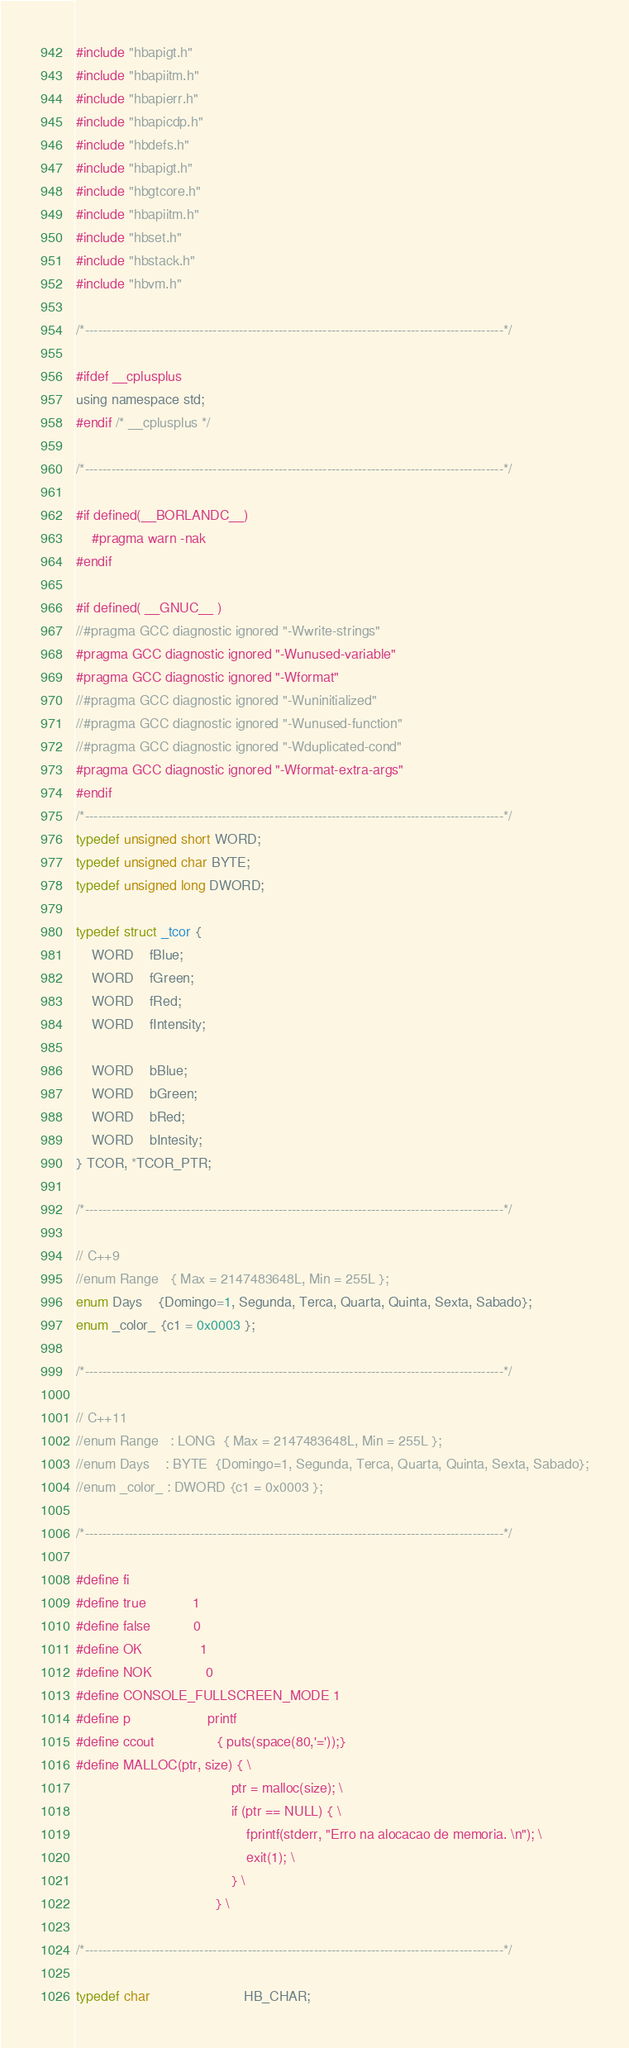Convert code to text. <code><loc_0><loc_0><loc_500><loc_500><_C_>#include "hbapigt.h"
#include "hbapiitm.h"
#include "hbapierr.h"
#include "hbapicdp.h"
#include "hbdefs.h"
#include "hbapigt.h"
#include "hbgtcore.h"
#include "hbapiitm.h"
#include "hbset.h"
#include "hbstack.h"
#include "hbvm.h"

/*-----------------------------------------------------------------------------------------------*/	
 
#ifdef __cplusplus
using namespace std;
#endif /* __cplusplus */

/*-----------------------------------------------------------------------------------------------*/	

#if defined(__BORLANDC__)	
	#pragma warn -nak	
#endif	

#if defined( __GNUC__ )
//#pragma GCC diagnostic ignored "-Wwrite-strings"
#pragma GCC diagnostic ignored "-Wunused-variable"
#pragma GCC diagnostic ignored "-Wformat"
//#pragma GCC diagnostic ignored "-Wuninitialized"
//#pragma GCC diagnostic ignored "-Wunused-function"
//#pragma GCC diagnostic ignored "-Wduplicated-cond"
#pragma GCC diagnostic ignored "-Wformat-extra-args"
#endif
/*-----------------------------------------------------------------------------------------------*/	
typedef unsigned short WORD;
typedef unsigned char BYTE;
typedef unsigned long DWORD;

typedef struct _tcor {
	WORD	fBlue;
	WORD 	fGreen;
	WORD	fRed;
	WORD	fIntensity;
	
	WORD 	bBlue;
	WORD 	bGreen;
	WORD 	bRed;
	WORD 	bIntesity;
} TCOR, *TCOR_PTR;

/*-----------------------------------------------------------------------------------------------*/	

// C++9
//enum Range   { Max = 2147483648L, Min = 255L };
enum Days    {Domingo=1, Segunda, Terca, Quarta, Quinta, Sexta, Sabado};
enum _color_ {c1 = 0x0003 };

/*-----------------------------------------------------------------------------------------------*/	

// C++11
//enum Range   : LONG  { Max = 2147483648L, Min = 255L };
//enum Days    : BYTE  {Domingo=1, Segunda, Terca, Quarta, Quinta, Sexta, Sabado};
//enum _color_ : DWORD {c1 = 0x0003 };

/*-----------------------------------------------------------------------------------------------*/	
 
#define fi 
#define true            1
#define false           0
#define OK	            1
#define NOK	            0
#define CONSOLE_FULLSCREEN_MODE 1
#define p 					printf
#define ccout 				{ puts(space(80,'='));}
#define MALLOC(ptr, size) { \
										ptr = malloc(size); \
										if (ptr == NULL) { \
											fprintf(stderr, "Erro na alocacao de memoria. \n"); \
											exit(1); \
										} \
									} \

/*-----------------------------------------------------------------------------------------------*/	

typedef char						HB_CHAR;</code> 